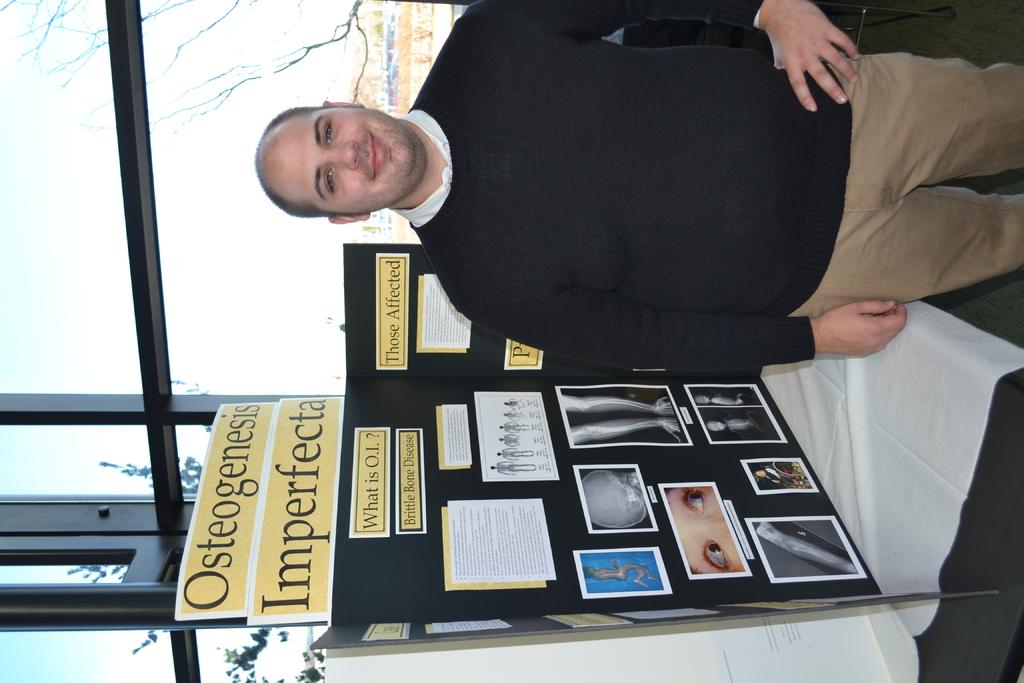What type of project is this?
Your response must be concise. Osteogenesis imperfecta. What is the first letter of the first word in the project's title?
Offer a very short reply. O. 